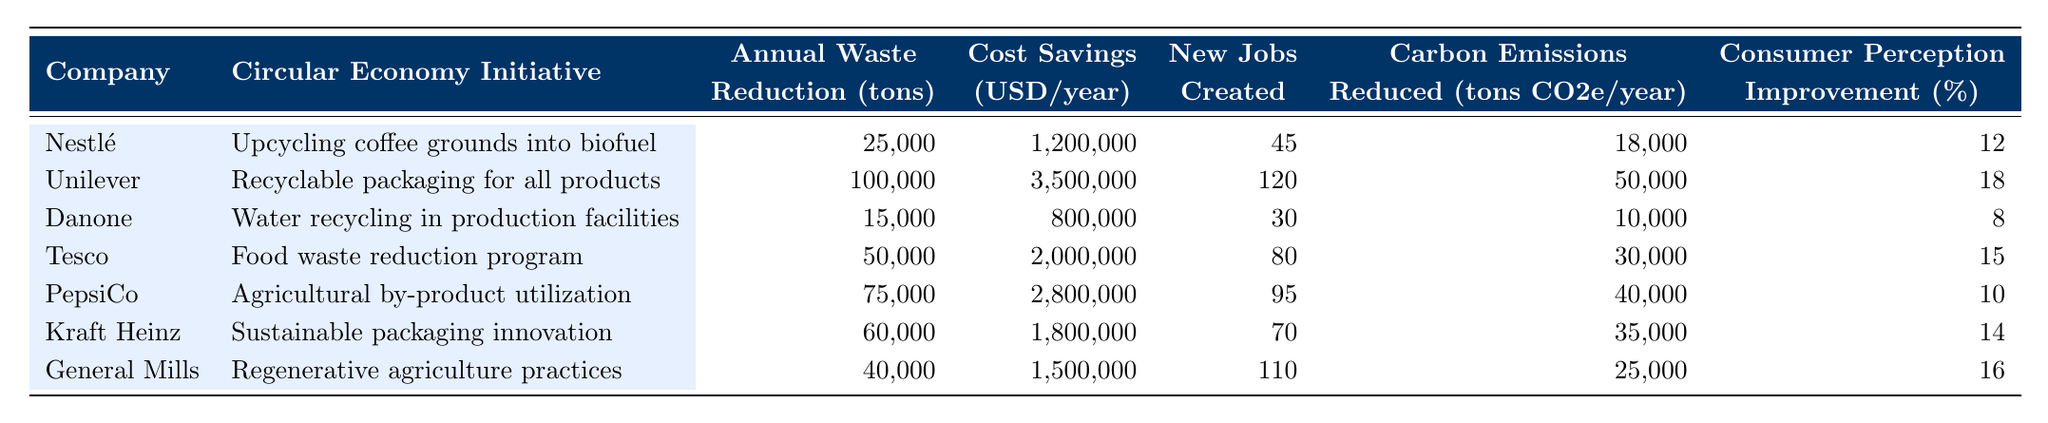What is the annual waste reduction achieved by Unilever? From the table, Unilever's annual waste reduction is stated directly as 100,000 tons.
Answer: 100,000 tons How much cost savings does Nestlé achieve per year? Looking at the table, Nestlé has an annual cost saving listed as 1,200,000 USD.
Answer: 1,200,000 USD Which company created the most new jobs, and how many? According to the table, Unilever created the most new jobs with a total of 120.
Answer: Unilever, 120 jobs What is the total annual waste reduction for all companies combined? To calculate the total, we add the annual waste reductions: 25,000 + 100,000 + 15,000 + 50,000 + 75,000 + 60,000 + 40,000 = 365,000 tons.
Answer: 365,000 tons Does Danone have a higher cost saving than Kraft Heinz? In the table, Danone's cost savings are 800,000 USD, while Kraft Heinz has 1,800,000 USD, indicating that Kraft Heinz has higher savings.
Answer: No What is the average percentage improvement in consumer perception across all companies? To find the average, we sum the consumer perception improvements: 12 + 18 + 8 + 15 + 10 + 14 + 16 = 93%. Dividing by 7 gives an average of 93/7 = 13.29%.
Answer: 13.29% Which initiative led to the highest carbon emissions reduction? The table shows that Unilever's initiative resulted in a carbon emissions reduction of 50,000 tons CO2e/year, which is the highest among all companies.
Answer: Unilever What company achieved the least annual waste reduction, and what was the amount? By looking at the waste reduction values, Danone achieved the least amount at 15,000 tons.
Answer: Danone, 15,000 tons Calculate the total cost savings for PepsiCo and Tesco. For PepsiCo, the cost saving is 2,800,000 USD and for Tesco, it is 2,000,000 USD. Adding these gives 2,800,000 + 2,000,000 = 4,800,000 USD.
Answer: 4,800,000 USD Is there a company whose consumer perception improvement is 10% or lower? The table indicates that PepsiCo and Danone have consumer perception improvements of 10% and 8% respectively, meaning there are companies below the 10% threshold.
Answer: Yes 